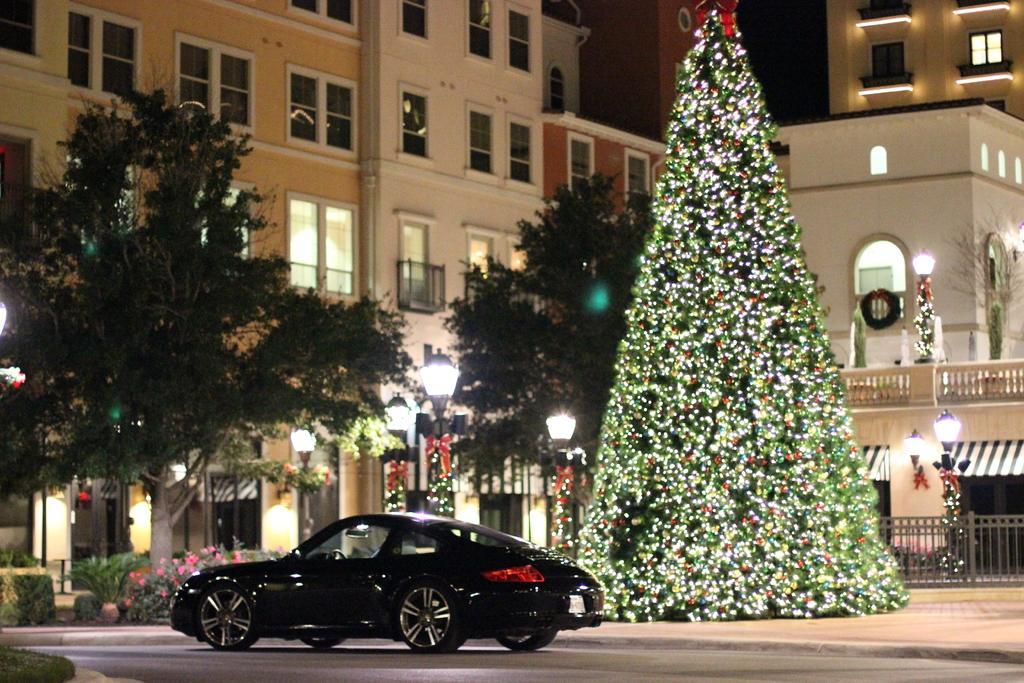In one or two sentences, can you explain what this image depicts? In this picture we can see a car on the road, plants, trees, lights, fences, Christmas tree and some objects and in the background we can see buildings with windows. 